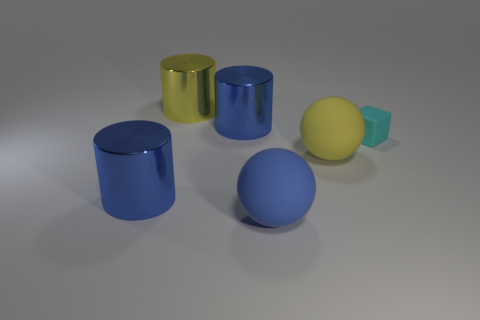Subtract all big blue cylinders. How many cylinders are left? 1 Subtract all blue blocks. How many blue cylinders are left? 2 Add 1 small cyan matte cubes. How many objects exist? 7 Subtract 1 balls. How many balls are left? 1 Subtract all blocks. How many objects are left? 5 Subtract all purple balls. Subtract all brown cylinders. How many balls are left? 2 Subtract all big shiny things. Subtract all cylinders. How many objects are left? 0 Add 1 big blue things. How many big blue things are left? 4 Add 2 purple metal cubes. How many purple metal cubes exist? 2 Subtract 0 red cubes. How many objects are left? 6 